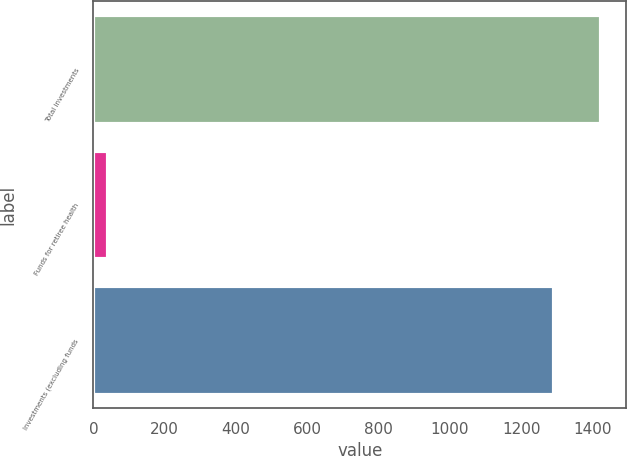Convert chart to OTSL. <chart><loc_0><loc_0><loc_500><loc_500><bar_chart><fcel>Total investments<fcel>Funds for retiree health<fcel>Investments (excluding funds<nl><fcel>1422.3<fcel>42<fcel>1293<nl></chart> 